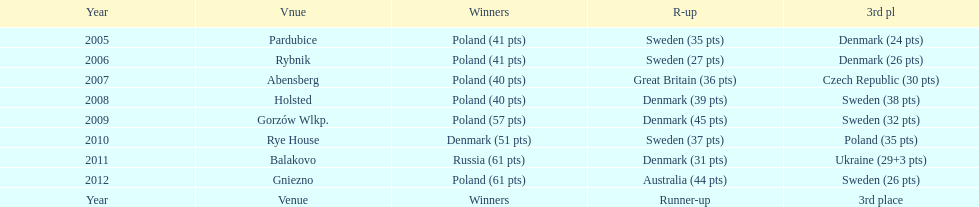What was the difference in final score between russia and denmark in 2011? 30. 